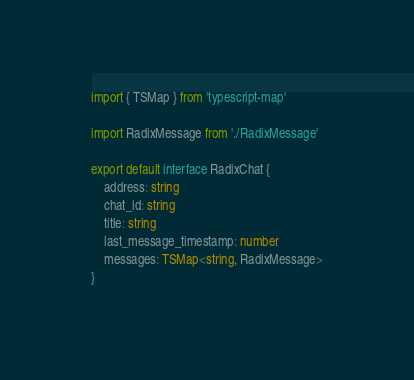Convert code to text. <code><loc_0><loc_0><loc_500><loc_500><_TypeScript_>import { TSMap } from 'typescript-map'

import RadixMessage from './RadixMessage'

export default interface RadixChat {
    address: string
    chat_id: string
    title: string
    last_message_timestamp: number
    messages: TSMap<string, RadixMessage>
}
</code> 